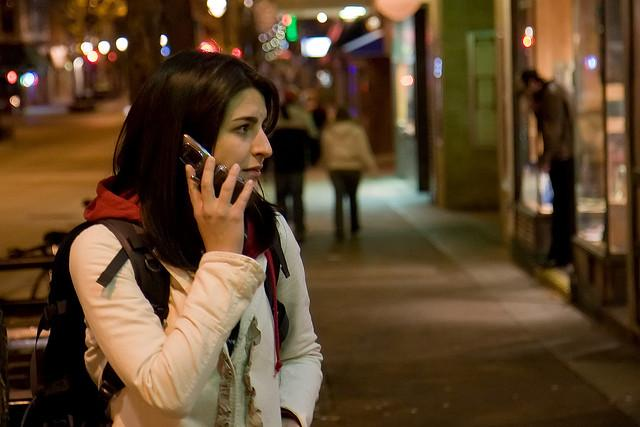What type of city district is this? Please explain your reasoning. commercial. She is in a commercial area. 